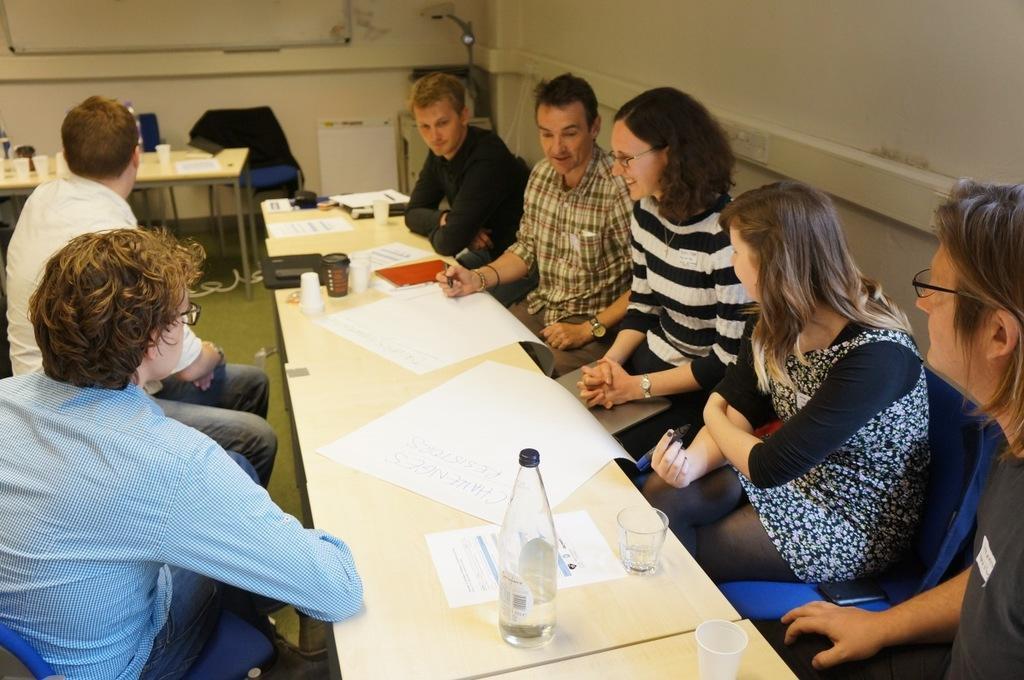In one or two sentences, can you explain what this image depicts? In the room there are people sitting on the chair in front of the table, on the table there are water bottle, glasses, papers and at the left corner of the picture there is another table in the room behind that there is a big wall. 